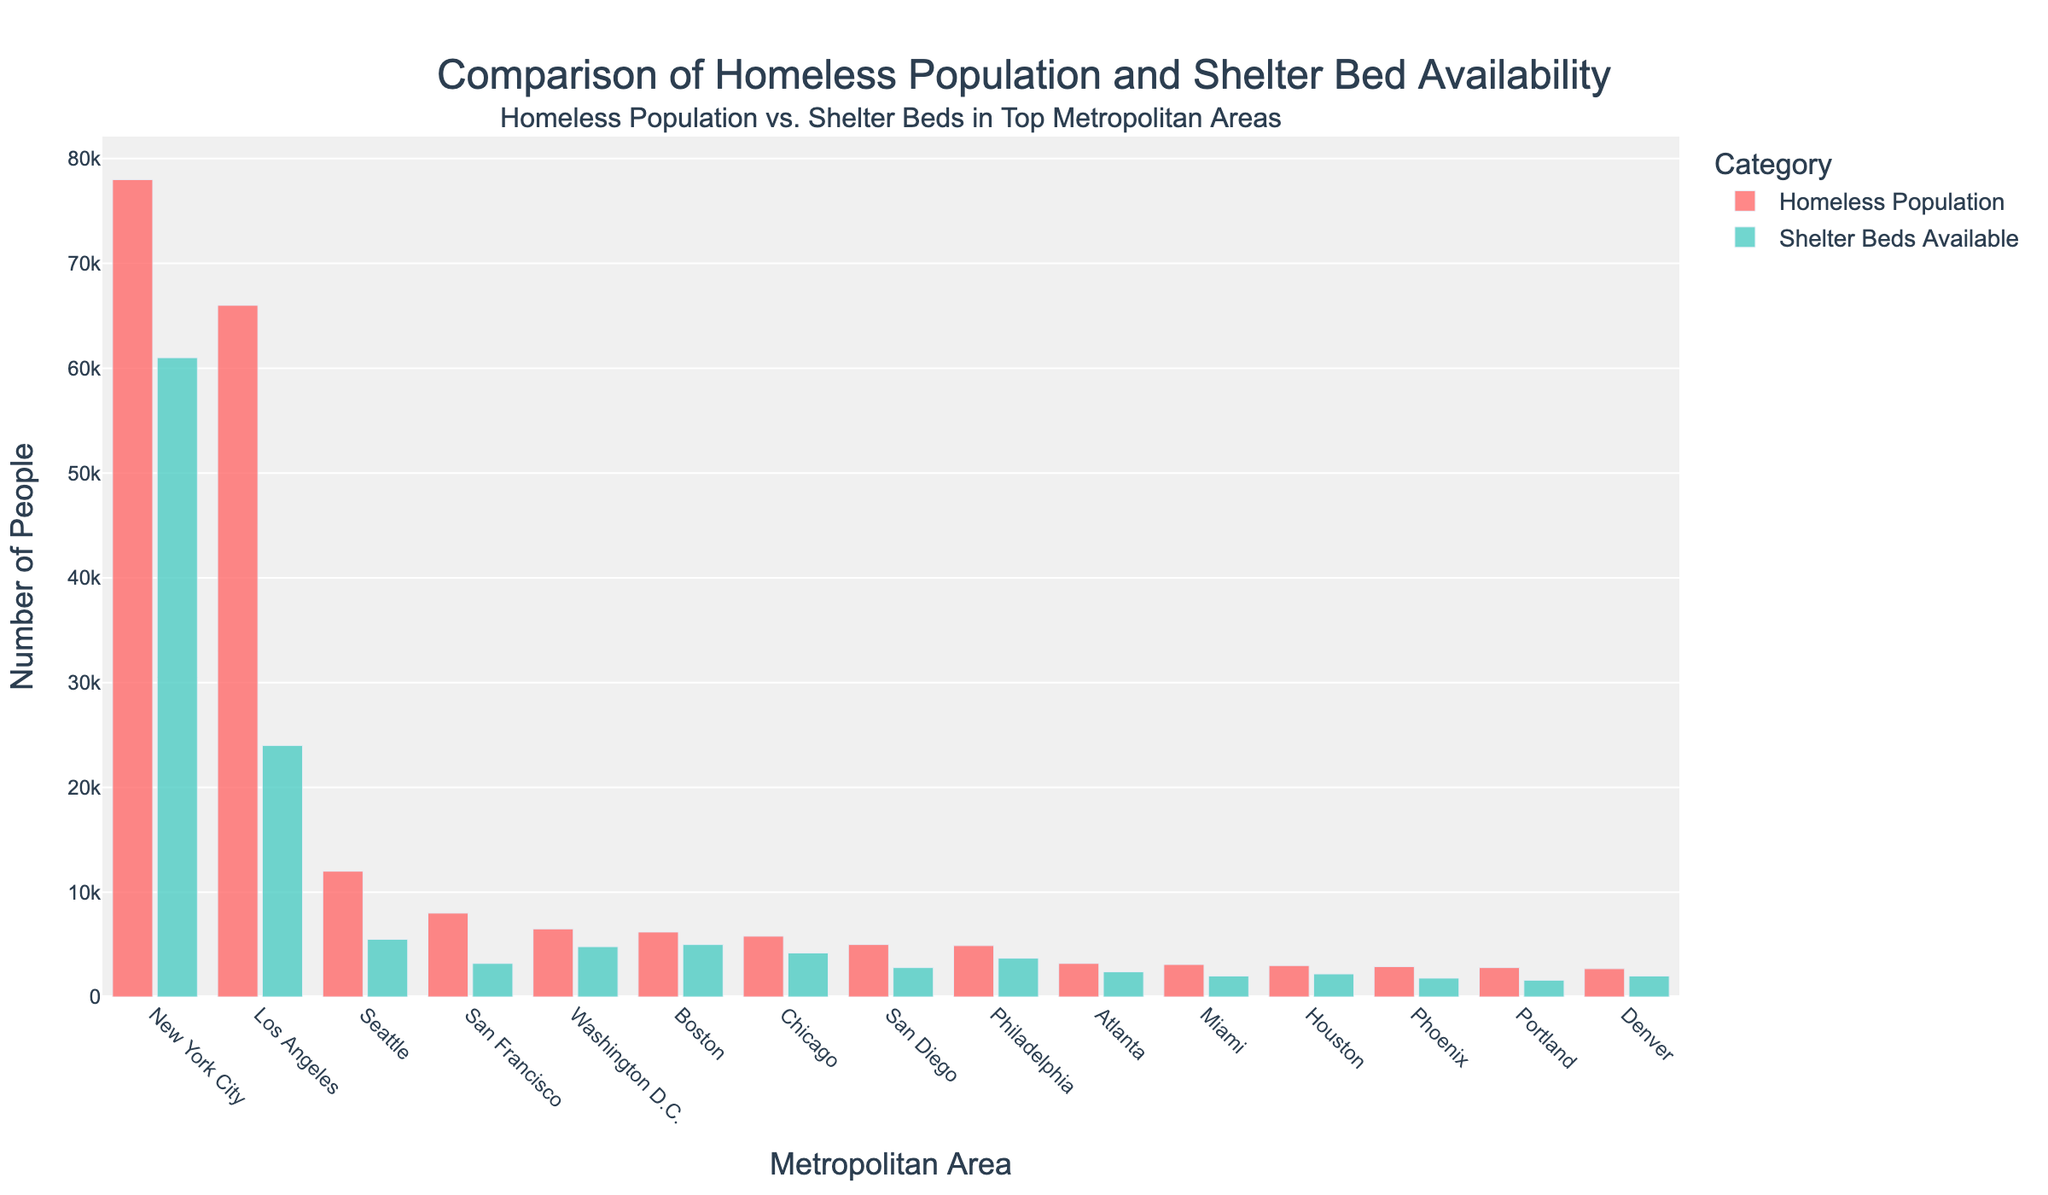Which metropolitan area has the highest homeless population? The metropolitan area with the highest homeless population can be identified by comparing the heights of the red bars representing the homeless population. The tallest red bar is for New York City.
Answer: New York City Which metropolitan areas have more shelter beds available than the homeless population? Compare the heights of the green bars (shelter beds available) and red bars (homeless population). The green bar must be taller than the red bar. Boston and Washington D.C. both have taller green bars than red bars.
Answer: Boston, Washington D.C How much larger is New York City's homeless population compared to Los Angeles? Subtract Los Angeles's homeless population from New York City's homeless population using the values on the y-axis. 78000 - 66000 = 12000.
Answer: 12000 Which metropolitan area has the smallest number of shelter beds available? Check the heights of the green bars and identify the shortest one. The shortest green bar corresponds to Portland.
Answer: Portland What is the average difference between the homeless population and shelter beds available for New York City and Los Angeles? Calculate the differences between the homeless populations and shelter beds available for both cities, then find their average. For New York City: 78000 - 61000 = 17000. For Los Angeles: 66000 - 24000 = 42000. The average difference is (17000 + 42000) / 2 = 29500.
Answer: 29500 What is the total number of shelter beds available across the top three metropolitan areas with the highest homeless population? Identify the top three metropolitan areas by homeless population (New York City, Los Angeles, and Seattle) and sum their shelter beds. 61000 + 24000 + 5500 = 90500.
Answer: 90500 Which has a greater homeless population: Atlanta or Miami? Compare the heights of the red bars for Atlanta and Miami. Atlanta's red bar is slightly taller than Miami's.
Answer: Atlanta How many more shelter beds are available in Boston compared to Philadelphia? Subtract the number of shelter beds available in Philadelphia from the number in Boston. 5000 - 3700 = 1300.
Answer: 1300 Which metropolitan area has the closest number of shelter beds and homeless population? Identify the smallest differences between the pairs of red and green bars. Washington D.C. has a homeless population of 6500 and 4800 shelter beds, a difference of 1700, which is the closest.
Answer: Washington D.C How does the homeless population in San Francisco compare to that in Houston? Compare the heights of the red bars for San Francisco and Houston. San Francisco's red bar is significantly taller than Houston's.
Answer: San Francisco 